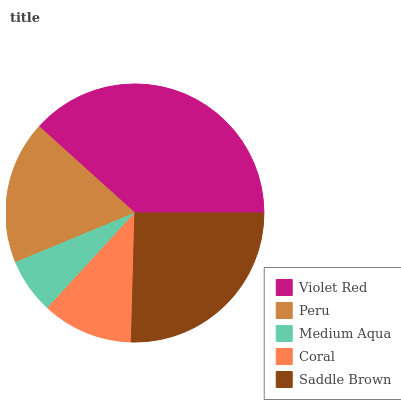Is Medium Aqua the minimum?
Answer yes or no. Yes. Is Violet Red the maximum?
Answer yes or no. Yes. Is Peru the minimum?
Answer yes or no. No. Is Peru the maximum?
Answer yes or no. No. Is Violet Red greater than Peru?
Answer yes or no. Yes. Is Peru less than Violet Red?
Answer yes or no. Yes. Is Peru greater than Violet Red?
Answer yes or no. No. Is Violet Red less than Peru?
Answer yes or no. No. Is Peru the high median?
Answer yes or no. Yes. Is Peru the low median?
Answer yes or no. Yes. Is Medium Aqua the high median?
Answer yes or no. No. Is Violet Red the low median?
Answer yes or no. No. 